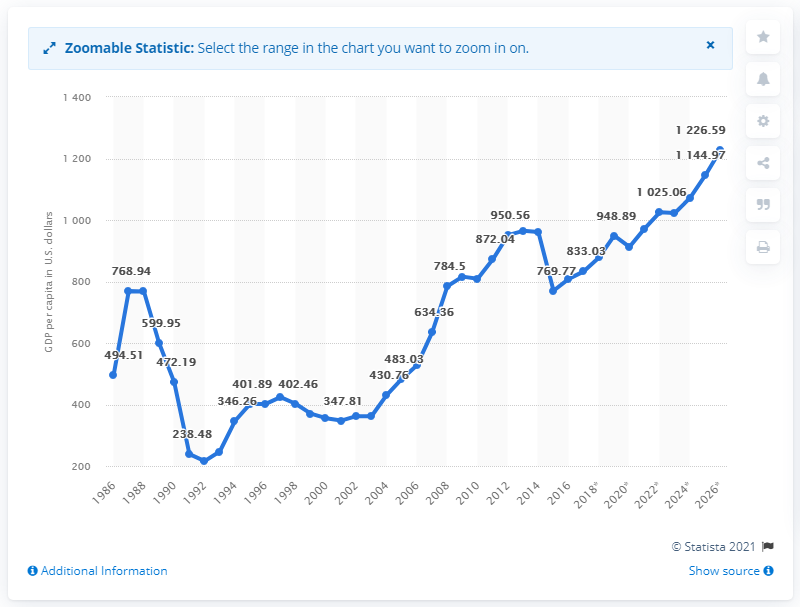Highlight a few significant elements in this photo. In 2016, the Gross Domestic Product (GDP) per capita of Uganda was $808.45 in United States Dollars. 